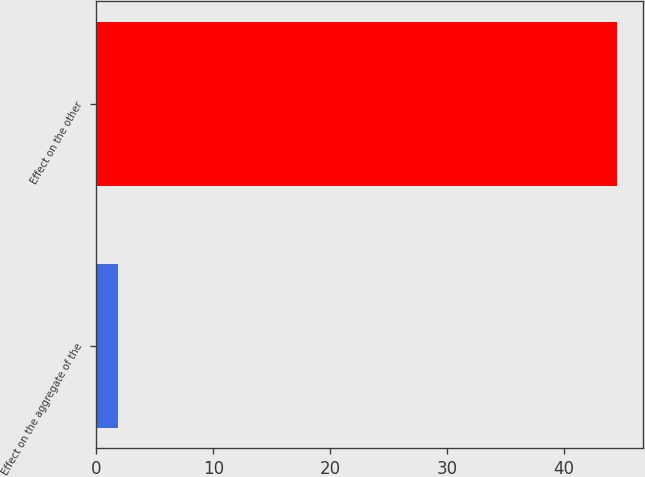Convert chart. <chart><loc_0><loc_0><loc_500><loc_500><bar_chart><fcel>Effect on the aggregate of the<fcel>Effect on the other<nl><fcel>1.8<fcel>44.5<nl></chart> 